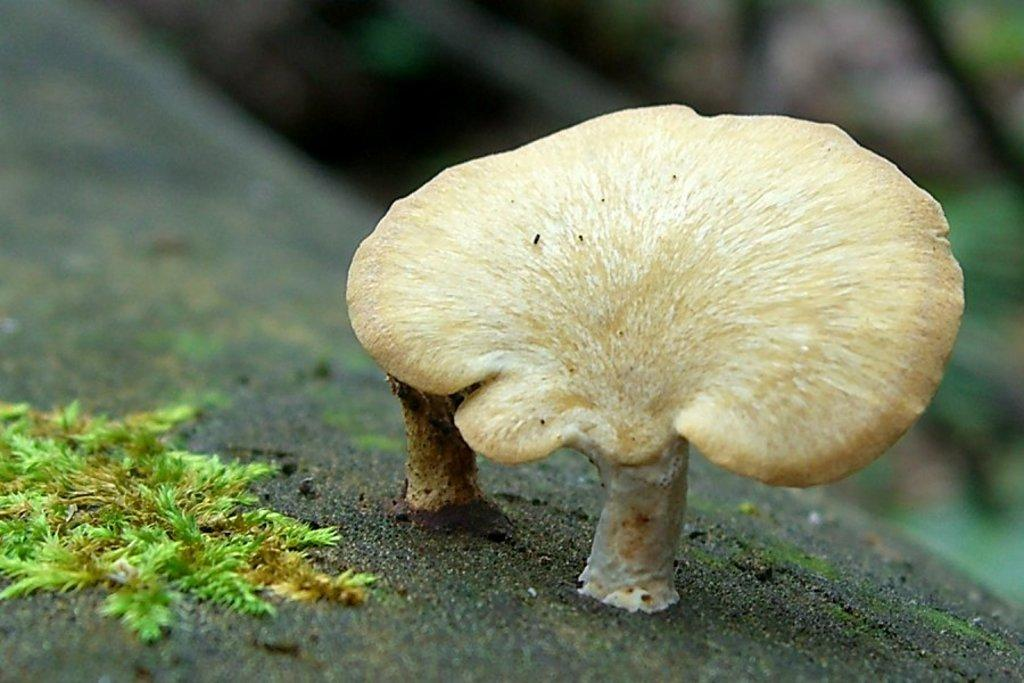What is the main subject of the image? The main subject of the image is a mushroom. Can you describe the color of the mushroom? The mushroom is cream in color. What type of vegetation is present in the image? There is grass in the image. How is the grass depicted in the image? The grass is blurred in the background. What is the surface on which the mushroom and grass are situated? There is ground visible in the image. What type of skirt can be seen in the image? There is no skirt present in the image; it features a mushroom and grass. Is there any smoke visible in the image? There is no smoke present in the image. 